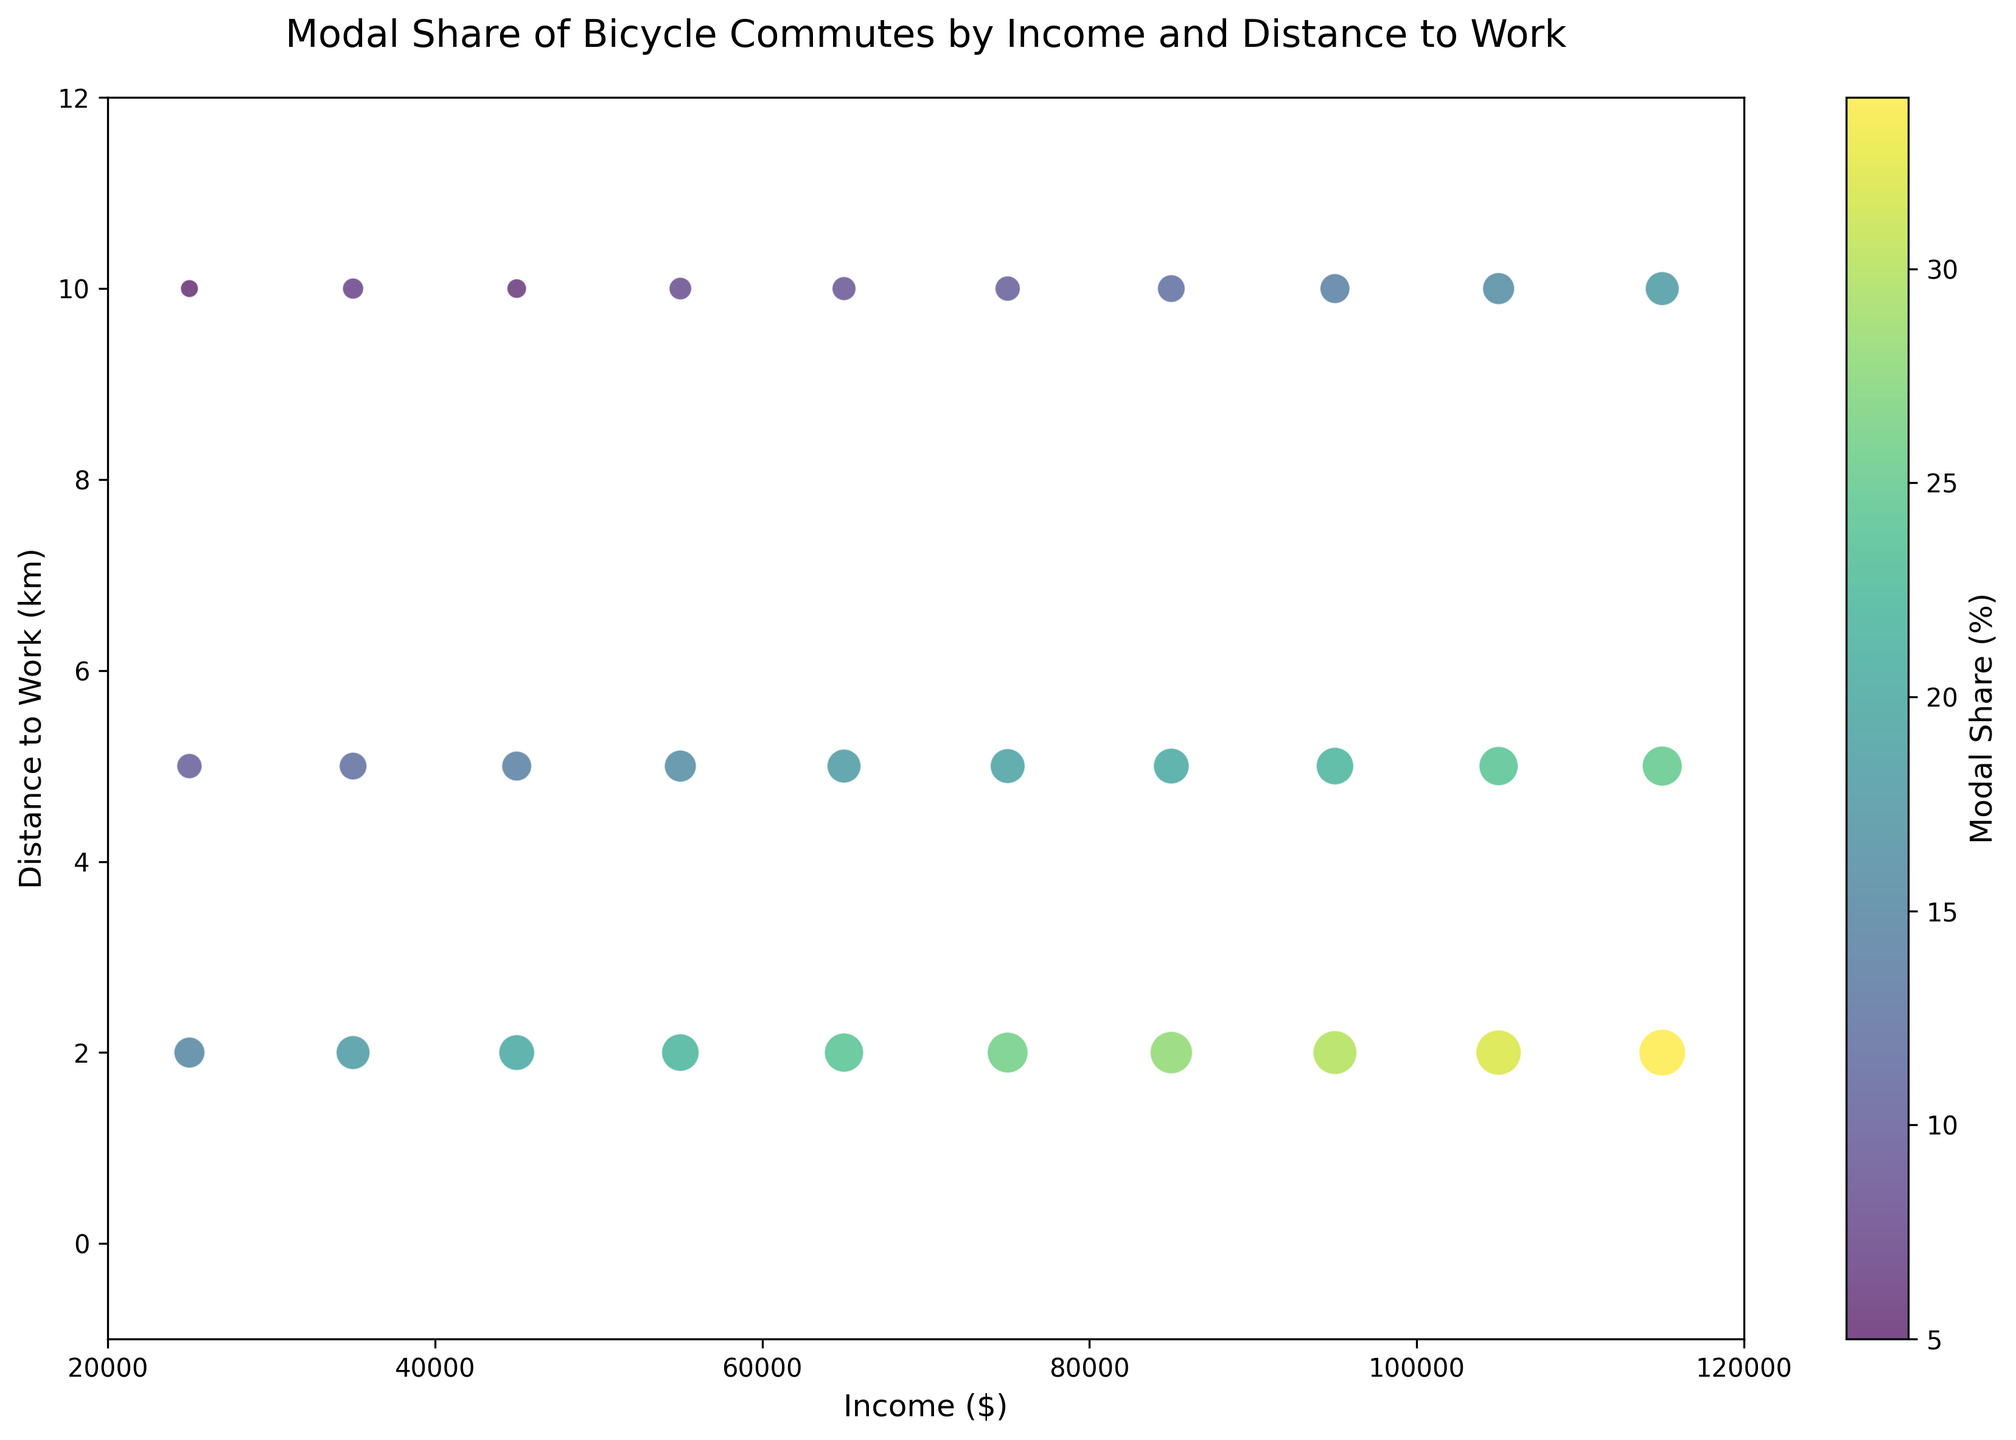What is the relationship between income and modal share? Observing the figure, higher-income levels correlate with higher modal shares for bicycle commutes across different distances. As income increases, the modal share tends to rise.
Answer: Higher income, higher modal share Which income category has the highest modal share at 2 km distance to work? Looking at the values associated with the 2 km distance on the x-axis, the income level of $115,000 has the largest bubble size and darkest color, indicating the highest modal share.
Answer: $115,000 How does the modal share change with distance to work for a $65,000 income? For $65,000 income, visually compare the bubble sizes at 2 km, 5 km, and 10 km distances. The bubble size decreases from 24% at 2 km, 18% at 5 km, to 9% at 10 km, indicating a decrease in modal share with an increase in distance.
Answer: Decreases Which distance category has the lowest modal share for low-income individuals ($25,000)? Look at the $25,000 income category and compare the bubble sizes at 2 km, 5 km, and 10 km distances. The smallest bubble and lightest color are seen at 10 km, representing a 5% modal share.
Answer: 10 km Is the modal share higher for a $55,000 income at 5 km or a $105,000 income at 10 km? Compare the bubble size for $55,000 at 5 km distance (16%) with that of $105,000 at 10 km distance (16%). The bubble size appears the same.
Answer: Equal Which bubble has the darkest color, indicating the highest modal share? Visually identify the darkest bubble, which appears at the $115,000 income level and 2 km distance, indicating a 34% modal share.
Answer: $115,000 at 2 km What's the trend in modal share as income increases for a fixed distance of 5 km? Observing the bubble sizes and colors at the 5 km distance, we see an increase in bubble size and darker color as income increases, showing a rise in modal share.
Answer: Increases For a distance of 10 km, what income level corresponds to the highest modal share? Look at the 10 km distance and compare the bubble sizes and colors. The $115,000 income level has the largest bubble, indicating an 18% modal share.
Answer: $115,000 Compare the modal share for $25,000 and $95,000 at 5 km distance. Which is greater? Observe the bubbles for 5 km at $25,000 (10%) and $95,000 (22%). The bubble for $95,000 is larger, indicating a higher modal share.
Answer: $95,000 How does modal share vary across different distances for a fixed highest income of $115,000? For $115,000 income, compare bubble sizes at 2 km (34%), 5 km (25%), and 10 km (18%). The modal share decreases as the distance increases.
Answer: Decreases 